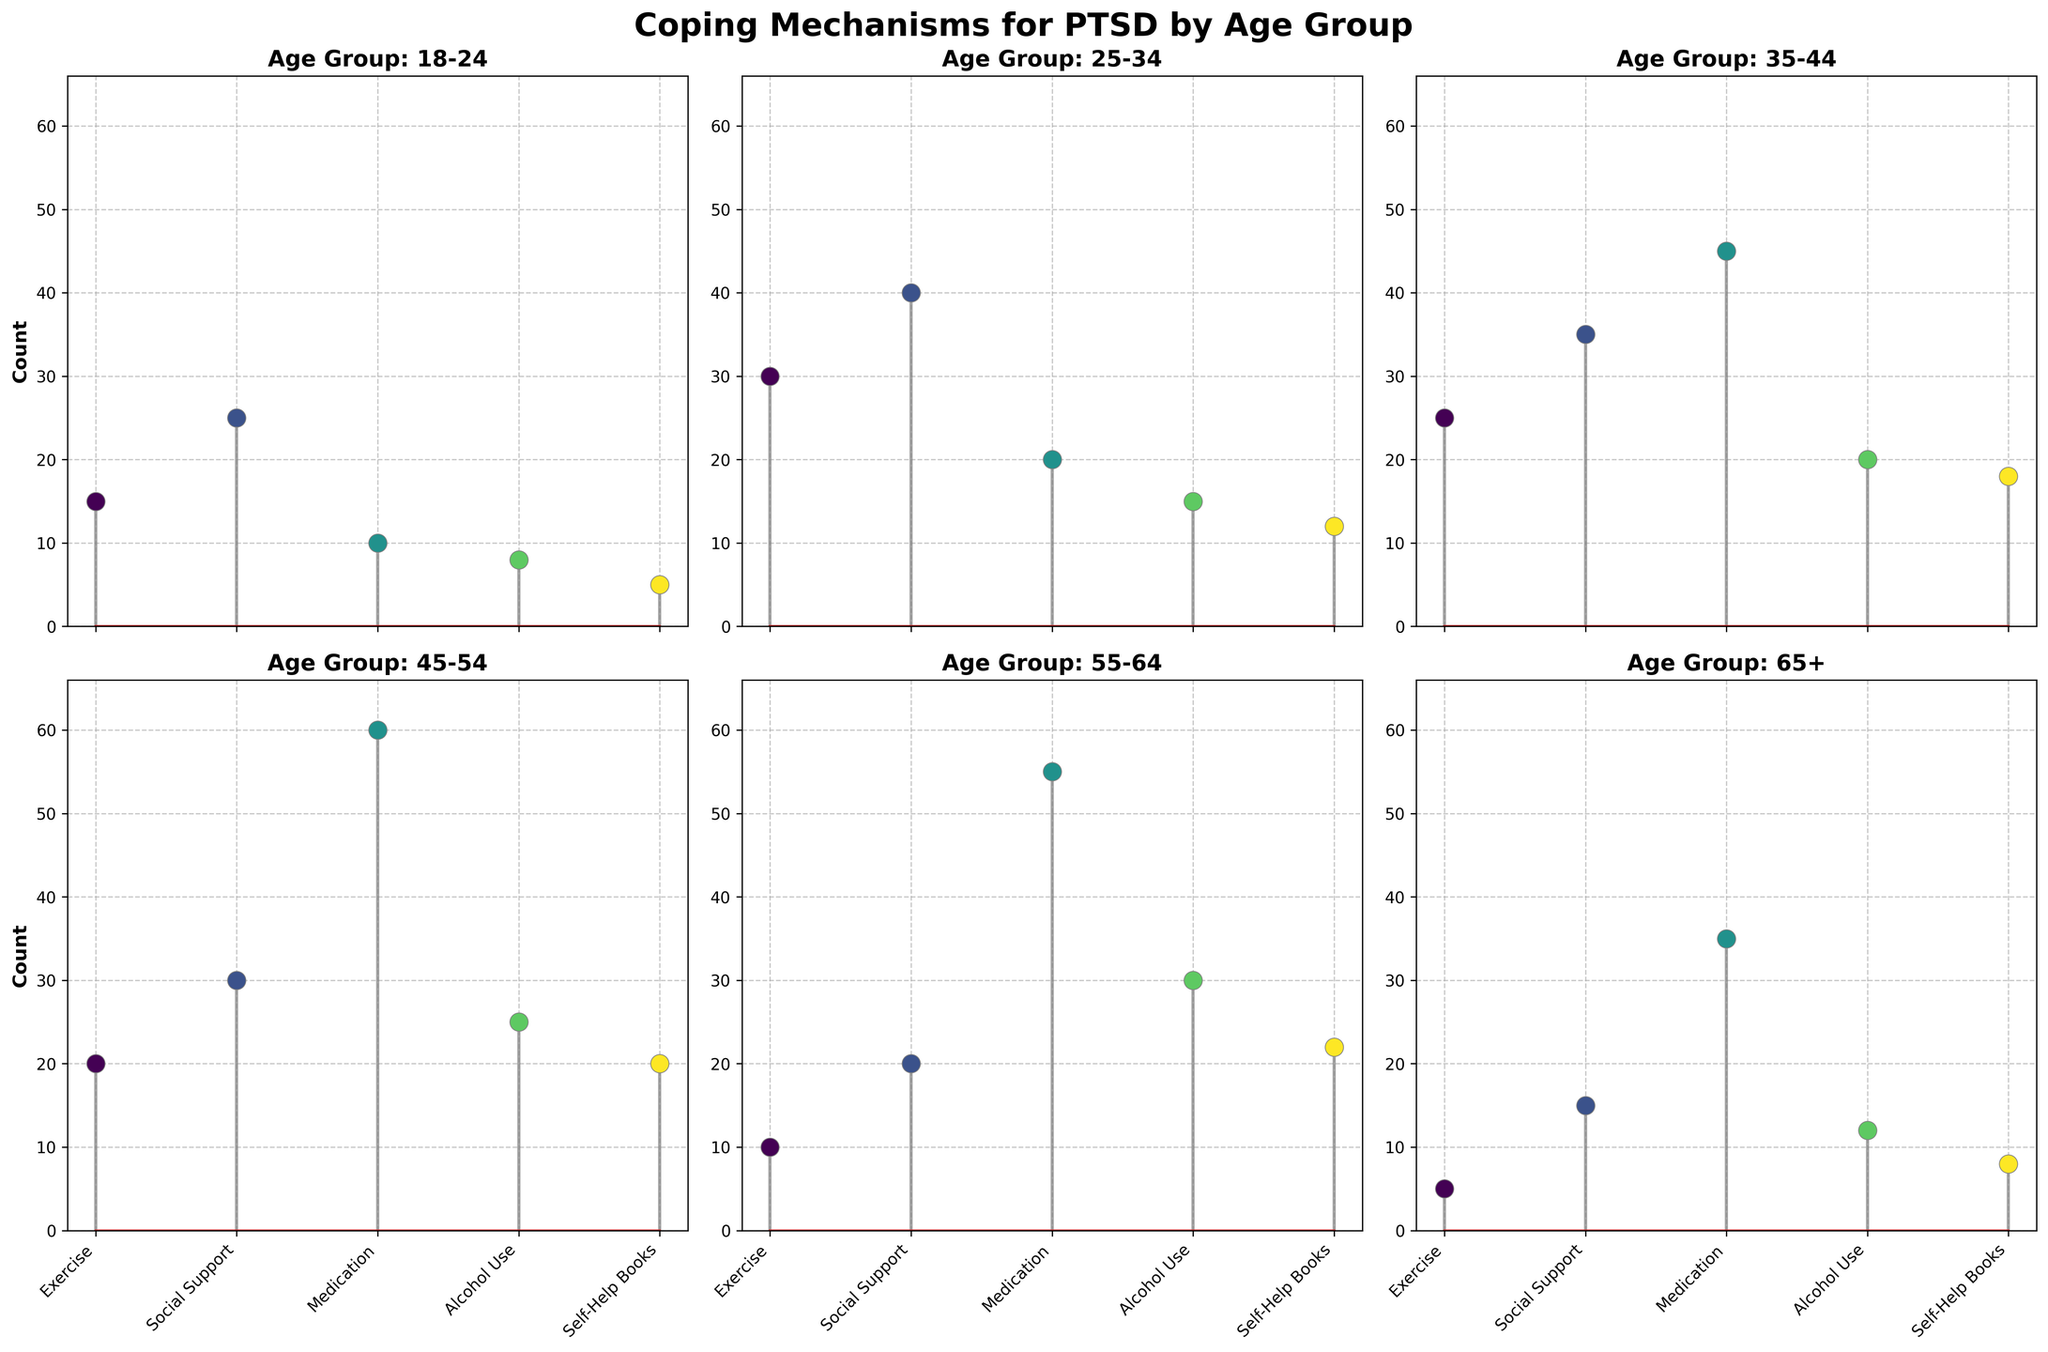What are the different coping mechanisms displayed in the plot? The subplot shows Exercise, Social Support, Medication, Alcohol Use, and Self-Help Books as coping mechanisms. Each subplot represents these mechanisms for different age groups.
Answer: Exercise, Social Support, Medication, Alcohol Use, Self-Help Books Which age group uses Exercise the most as a coping mechanism? By comparing the height of the stems for Exercise in each subplot, we can see that the 25-34 age group has the highest stem.
Answer: 25-34 What is the total count of Medication usage across all age groups? Summing the counts for Medication in each subplot: 10 (18-24) + 20 (25-34) + 45 (35-44) + 60 (45-54) + 55 (55-64) + 35 (65+). The total is 225.
Answer: 225 Which age group has the lowest count for Social Support? By looking at the height of the stems labeled "Social Support" in each subplot, the 65+ age group has the lowest count.
Answer: 65+ Is the use of Alcohol more common in younger or older age groups? Comparing the stems for Alcohol Use, younger age groups (18-24 and 25-34) have lower counts compared to older age groups (45-54, 55-64). Thus, Alcohol use is more common in older age groups.
Answer: Older age groups How does the count for Self-Help Books for ages 35-44 compare to ages 55-64? The stem plot shows 18 for ages 35-44 and 22 for ages 55-64. The count is higher for ages 55-64 by 4.
Answer: 55-64 has 4 more What trend do you observe in Medication usage as age increases? Observing each subplot for Medication, the count generally increases with age, peaking in the age group 45-54, and then decreasing slightly in 55-64 and 65+.
Answer: Increases with age up to 45-54, then slightly decreases Which coping mechanism is most prevalent in the 18-24 age group? By comparing the height of the stems within the 18-24 age group subplot, Social Support has the highest count.
Answer: Social Support What is the difference in Exercise count between the 18-24 and 55-64 age groups? The subplot shows 15 for 18-24 and 10 for 55-64. The difference is 5.
Answer: 5 Among all age groups, which coping mechanism has the highest single count? By inspecting each subplot, Medication in the 45-54 age group has the highest single count of 60.
Answer: Medication in 45-54 